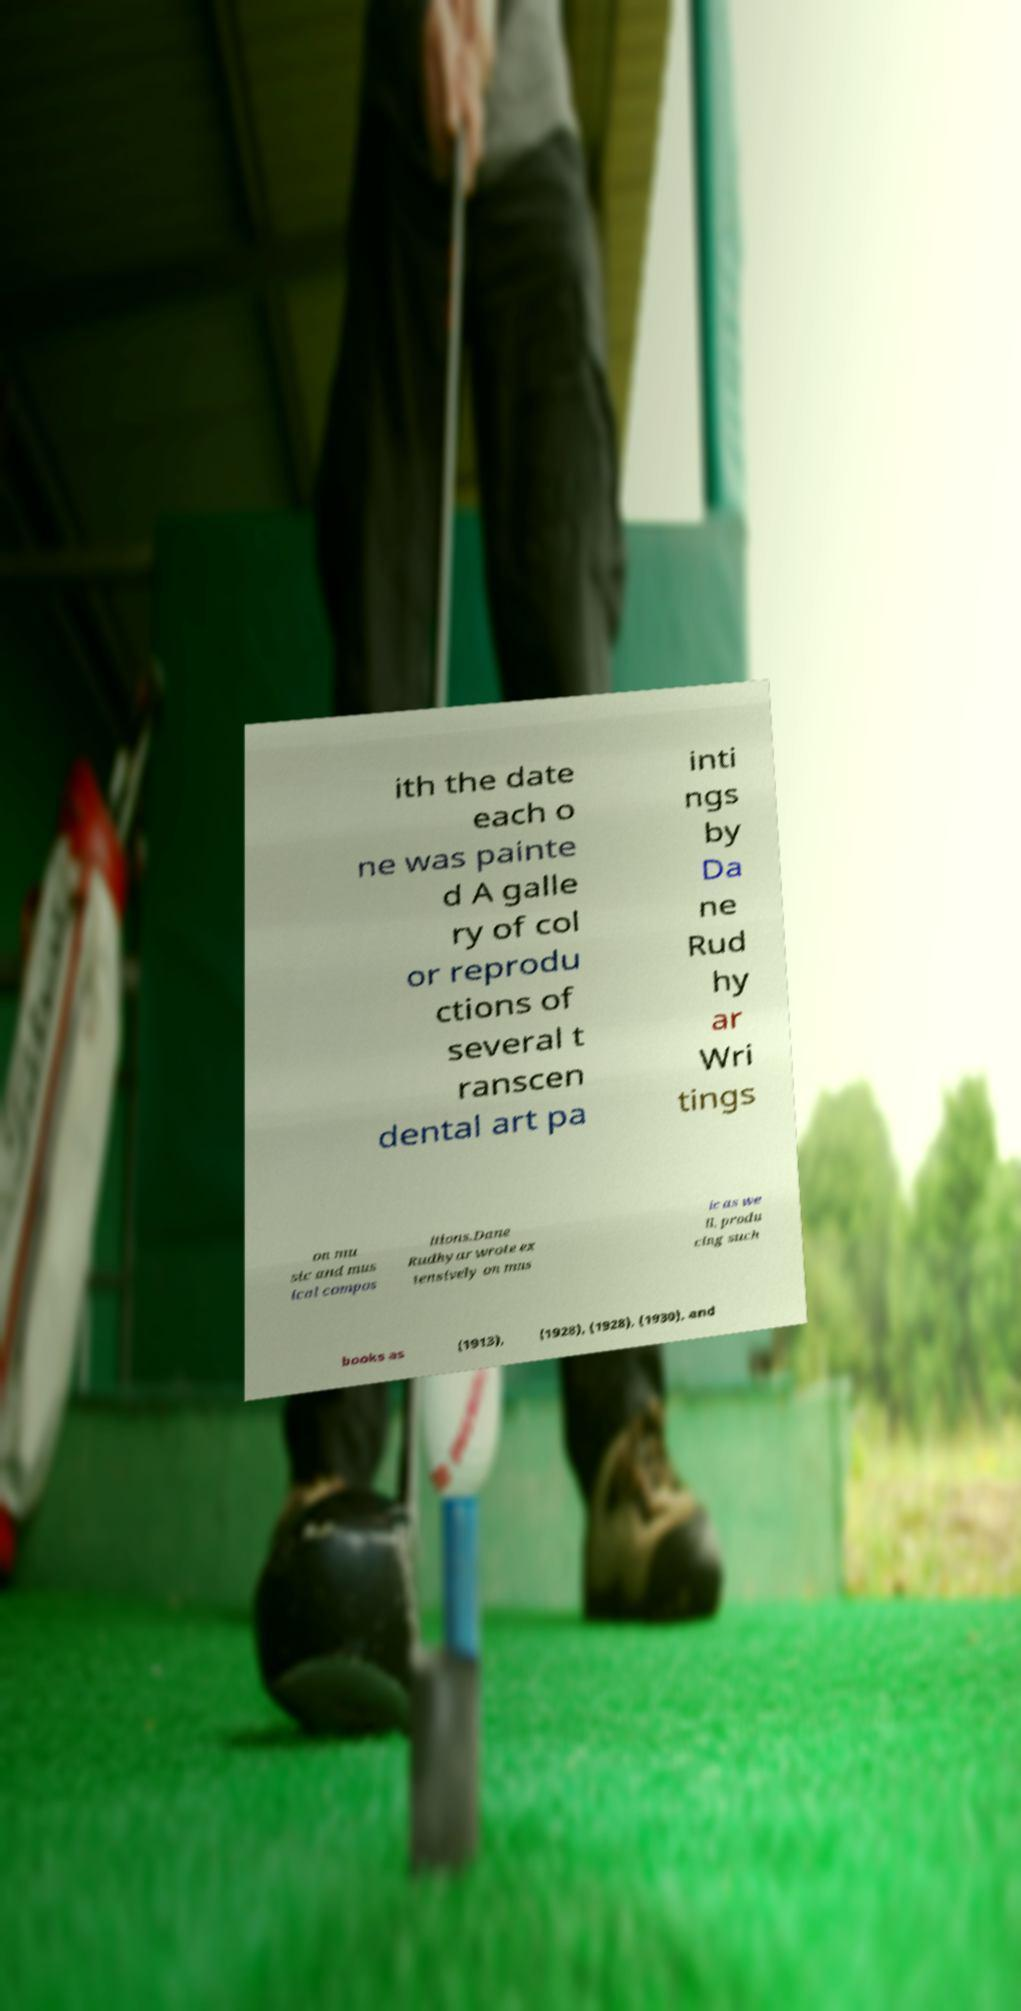For documentation purposes, I need the text within this image transcribed. Could you provide that? ith the date each o ne was painte d A galle ry of col or reprodu ctions of several t ranscen dental art pa inti ngs by Da ne Rud hy ar Wri tings on mu sic and mus ical compos itions.Dane Rudhyar wrote ex tensively on mus ic as we ll, produ cing such books as (1913), (1928), (1928), (1930), and 